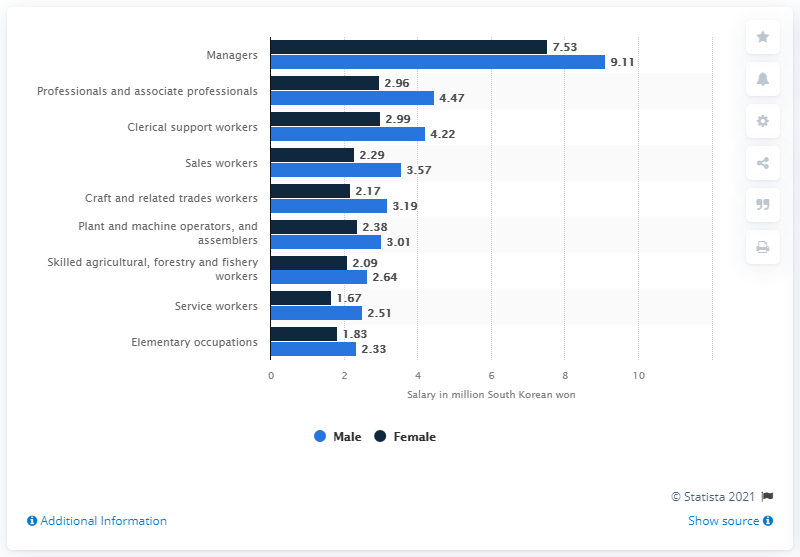List a handful of essential elements in this visual. According to data from 2020, female managers in South Korea earned an average of 7,530 won per month. In 2020, male managers in South Korea earned an average of 9,110 South Korean won per month. 